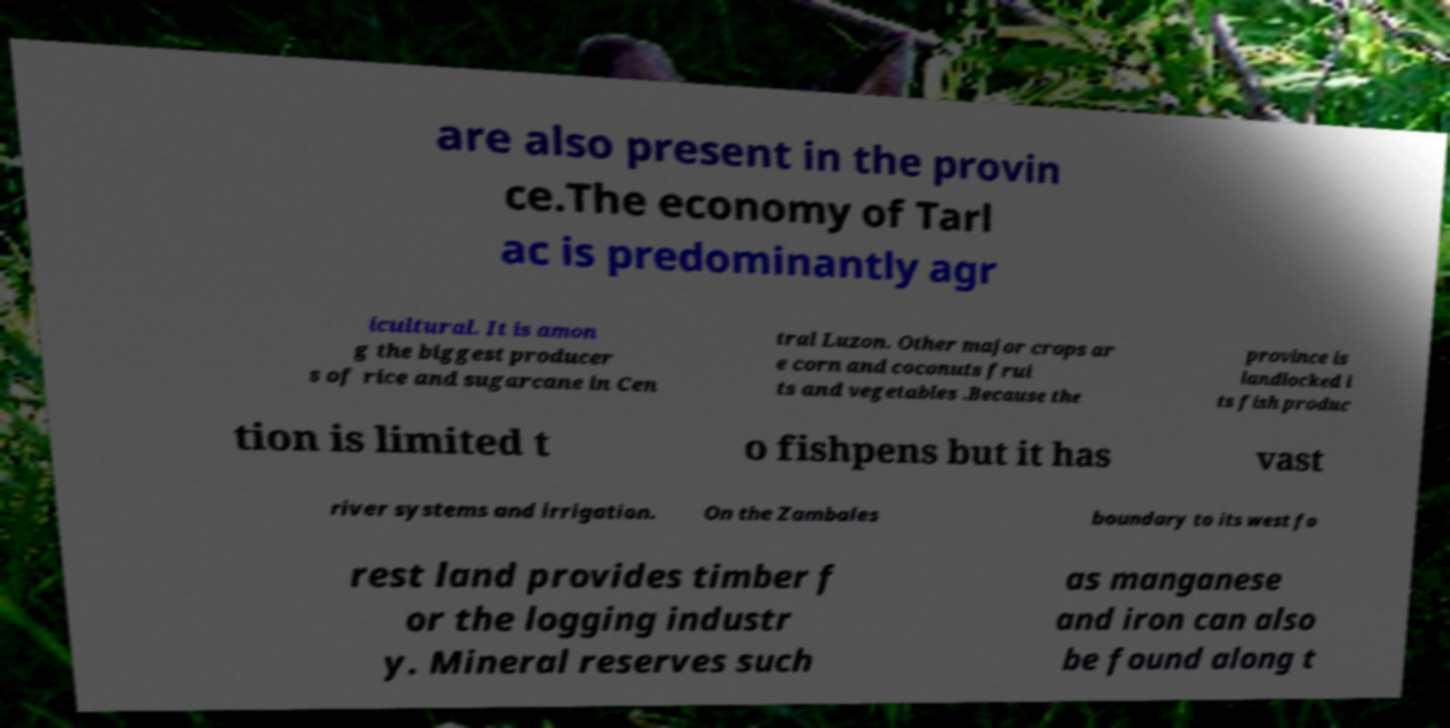For documentation purposes, I need the text within this image transcribed. Could you provide that? are also present in the provin ce.The economy of Tarl ac is predominantly agr icultural. It is amon g the biggest producer s of rice and sugarcane in Cen tral Luzon. Other major crops ar e corn and coconuts frui ts and vegetables .Because the province is landlocked i ts fish produc tion is limited t o fishpens but it has vast river systems and irrigation. On the Zambales boundary to its west fo rest land provides timber f or the logging industr y. Mineral reserves such as manganese and iron can also be found along t 